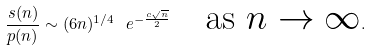<formula> <loc_0><loc_0><loc_500><loc_500>\frac { s ( n ) } { p ( n ) } \sim ( 6 n ) ^ { 1 / 4 } \ e ^ { - \frac { c \sqrt { n } } { 2 } } \quad \text {as $n\rightarrow \infty$} .</formula> 